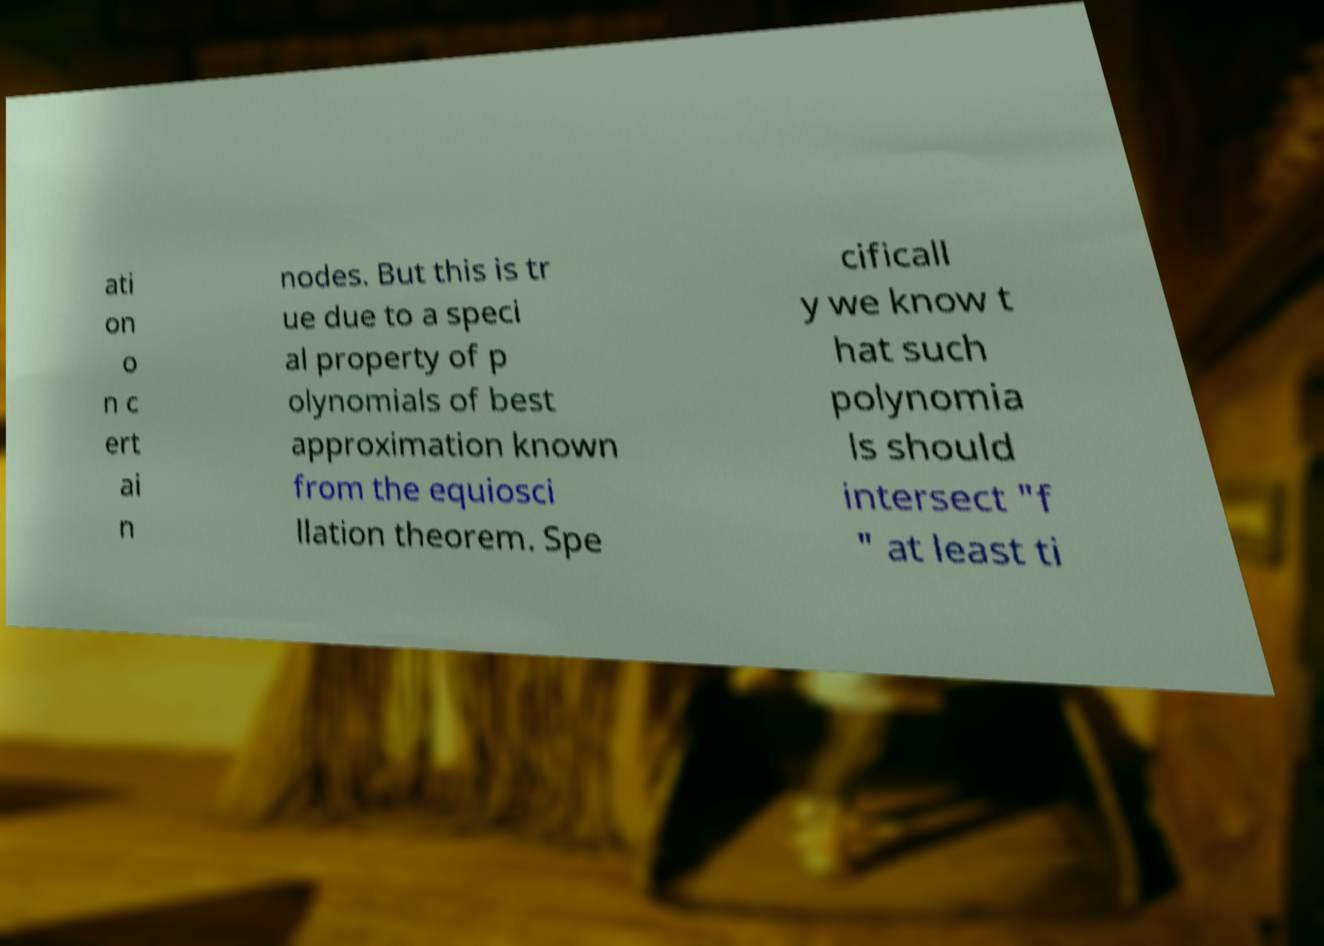There's text embedded in this image that I need extracted. Can you transcribe it verbatim? ati on o n c ert ai n nodes. But this is tr ue due to a speci al property of p olynomials of best approximation known from the equiosci llation theorem. Spe cificall y we know t hat such polynomia ls should intersect "f " at least ti 